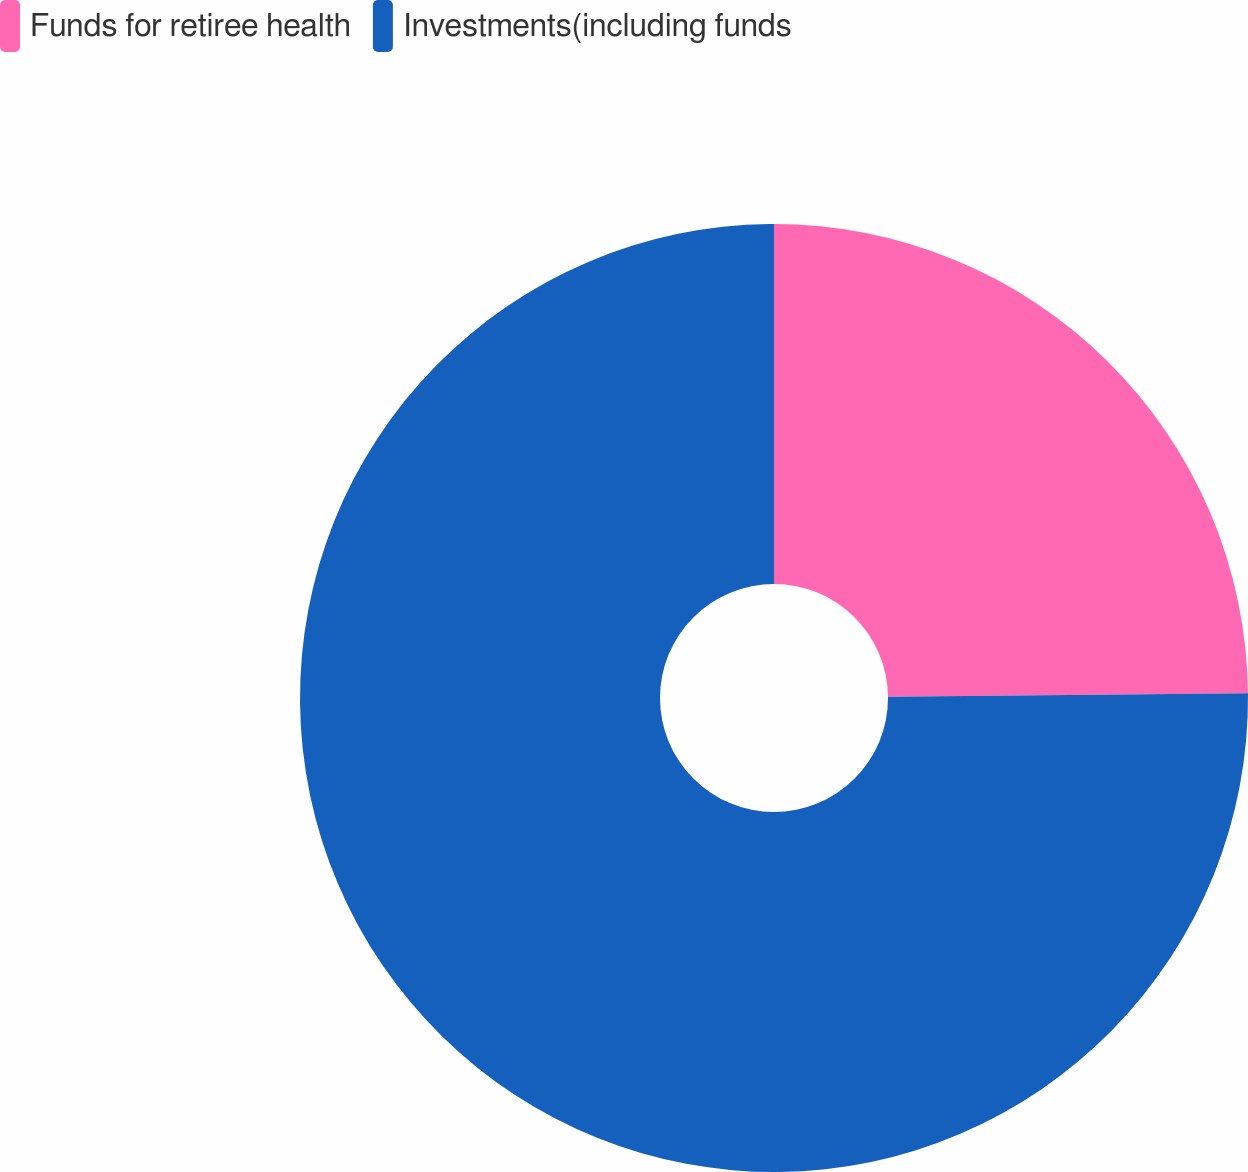<chart> <loc_0><loc_0><loc_500><loc_500><pie_chart><fcel>Funds for retiree health<fcel>Investments(including funds<nl><fcel>24.84%<fcel>75.16%<nl></chart> 